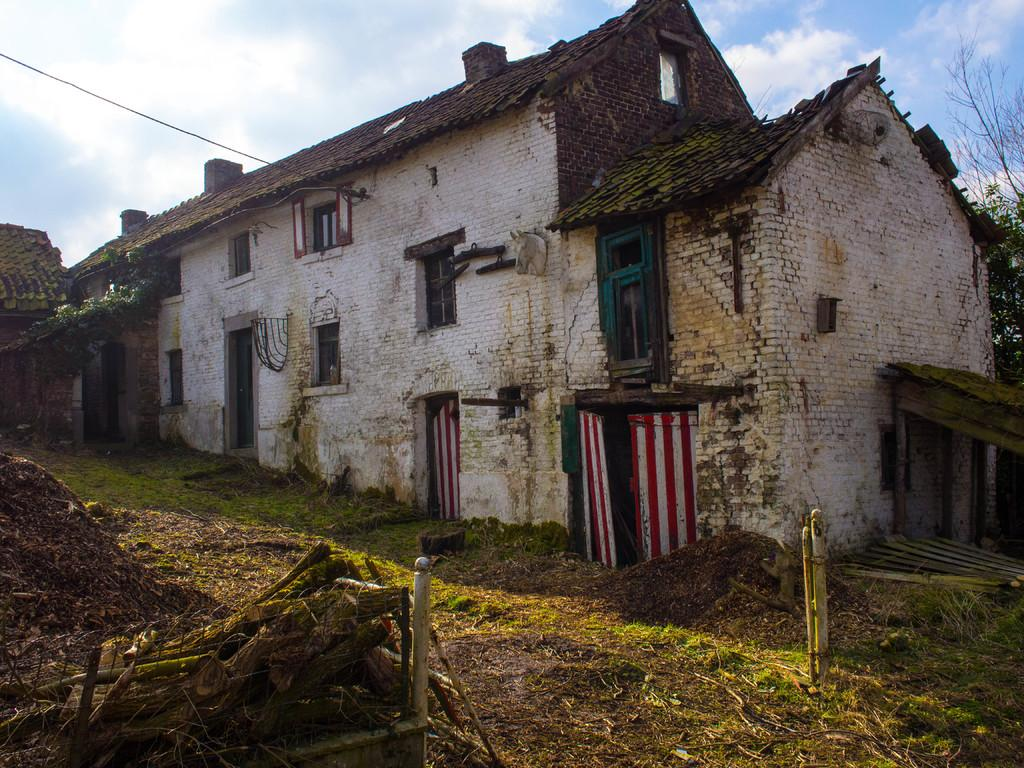What can be seen in the foreground of the picture? There are wooden logs, mud, and grass visible in the foreground of the picture. What is located in the center of the picture? There are buildings and trees present in the center of the picture. What is the weather like in the image? The sky is sunny in the image. Can you see someone swimming in the picture? There is no swimming activity depicted in the image. Is there a bike visible in the picture? There is no bike present in the image. 